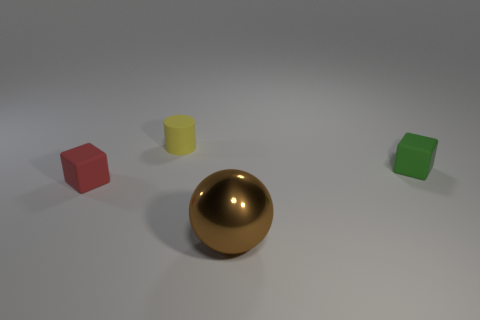Add 1 tiny metal cylinders. How many objects exist? 5 Subtract all yellow cylinders. How many blue blocks are left? 0 Add 2 big metallic things. How many big metallic things are left? 3 Add 2 tiny matte spheres. How many tiny matte spheres exist? 2 Subtract all green blocks. How many blocks are left? 1 Subtract 0 yellow cubes. How many objects are left? 4 Subtract all balls. How many objects are left? 3 Subtract all blue balls. Subtract all yellow cubes. How many balls are left? 1 Subtract all small gray spheres. Subtract all cylinders. How many objects are left? 3 